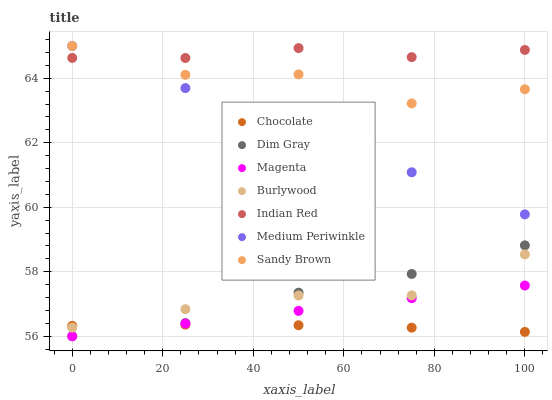Does Chocolate have the minimum area under the curve?
Answer yes or no. Yes. Does Indian Red have the maximum area under the curve?
Answer yes or no. Yes. Does Burlywood have the minimum area under the curve?
Answer yes or no. No. Does Burlywood have the maximum area under the curve?
Answer yes or no. No. Is Medium Periwinkle the smoothest?
Answer yes or no. Yes. Is Sandy Brown the roughest?
Answer yes or no. Yes. Is Burlywood the smoothest?
Answer yes or no. No. Is Burlywood the roughest?
Answer yes or no. No. Does Dim Gray have the lowest value?
Answer yes or no. Yes. Does Burlywood have the lowest value?
Answer yes or no. No. Does Sandy Brown have the highest value?
Answer yes or no. Yes. Does Burlywood have the highest value?
Answer yes or no. No. Is Burlywood less than Sandy Brown?
Answer yes or no. Yes. Is Sandy Brown greater than Burlywood?
Answer yes or no. Yes. Does Magenta intersect Dim Gray?
Answer yes or no. Yes. Is Magenta less than Dim Gray?
Answer yes or no. No. Is Magenta greater than Dim Gray?
Answer yes or no. No. Does Burlywood intersect Sandy Brown?
Answer yes or no. No. 